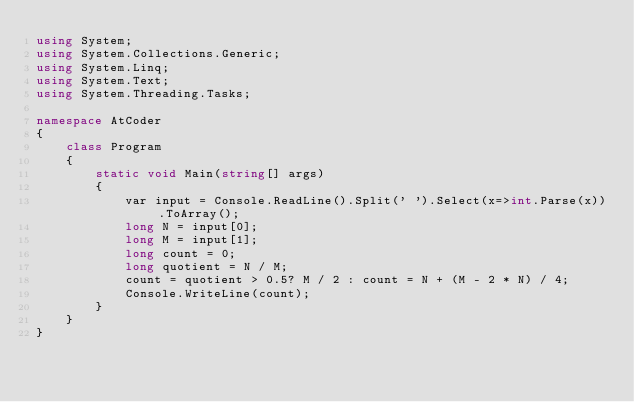<code> <loc_0><loc_0><loc_500><loc_500><_C#_>using System;
using System.Collections.Generic;
using System.Linq;
using System.Text;
using System.Threading.Tasks;

namespace AtCoder
{
	class Program
	{
		static void Main(string[] args)
		{
			var input = Console.ReadLine().Split(' ').Select(x=>int.Parse(x)).ToArray();
			long N = input[0];
			long M = input[1];
			long count = 0;
			long quotient = N / M;
			count = quotient > 0.5? M / 2 : count = N + (M - 2 * N) / 4;
			Console.WriteLine(count);
		}
	}
}
</code> 